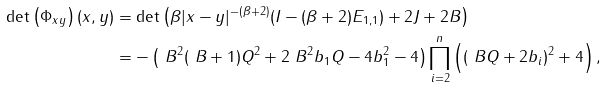<formula> <loc_0><loc_0><loc_500><loc_500>\det \left ( \Phi _ { x y } \right ) ( x , y ) & = \det \left ( \beta | x - y | ^ { - ( \beta + 2 ) } ( I - ( \beta + 2 ) E _ { 1 , 1 } ) + 2 J + 2 B \right ) \\ & = - \left ( \ B ^ { 2 } ( \ B + 1 ) Q ^ { 2 } + 2 \ B ^ { 2 } b _ { 1 } Q - 4 b _ { 1 } ^ { 2 } - 4 \right ) \prod _ { i = 2 } ^ { n } \left ( \left ( \ B Q + 2 b _ { i } \right ) ^ { 2 } + 4 \right ) ,</formula> 